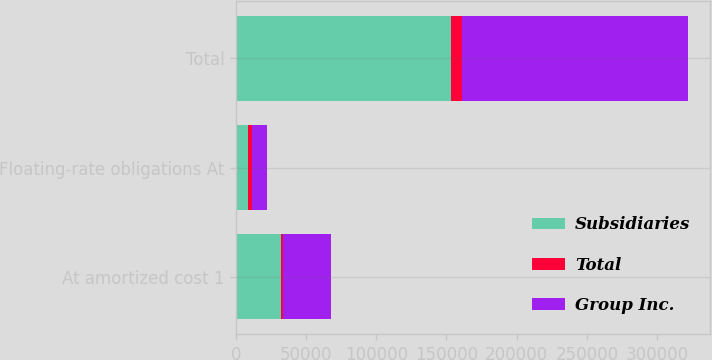Convert chart to OTSL. <chart><loc_0><loc_0><loc_500><loc_500><stacked_bar_chart><ecel><fcel>At amortized cost 1<fcel>Floating-rate obligations At<fcel>Total<nl><fcel>Subsidiaries<fcel>31741<fcel>8671<fcel>153513<nl><fcel>Total<fcel>1959<fcel>2549<fcel>7452<nl><fcel>Group Inc.<fcel>33700<fcel>11220<fcel>160965<nl></chart> 